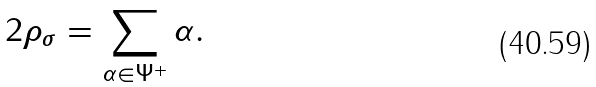Convert formula to latex. <formula><loc_0><loc_0><loc_500><loc_500>2 \rho _ { \sigma } = \sum _ { \alpha \in \Psi ^ { + } } \alpha .</formula> 